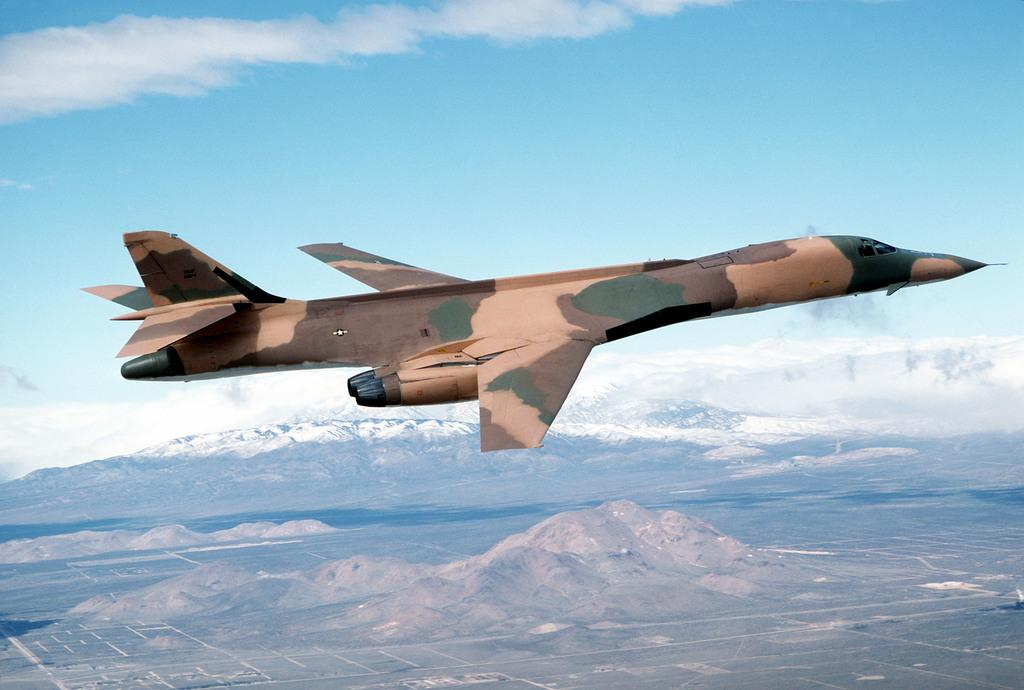What is the main subject of the image? The main subject of the image is an airplane flying. What can be seen in the background of the image? Mountains and the sky are visible in the background of the image. What is the condition of the sky in the image? The sky is visible in the background of the image, and clouds are present. Can you tell me how many yaks are grazing on the mountains in the image? There are no yaks present in the image; it features an airplane flying and mountains in the background. What type of apple is being used to drain the airplane's fuel in the image? There is no apple or fuel draining activity depicted in the image; it simply shows an airplane flying and mountains in the background. 